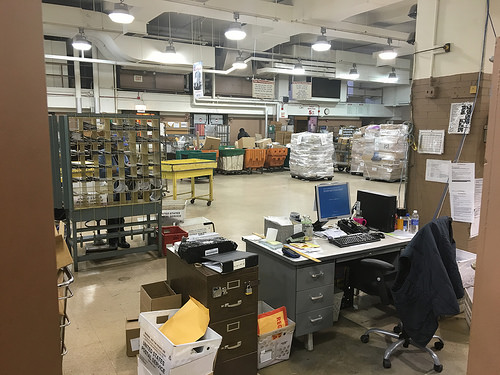<image>
Can you confirm if the chair is to the right of the drawers? Yes. From this viewpoint, the chair is positioned to the right side relative to the drawers. 